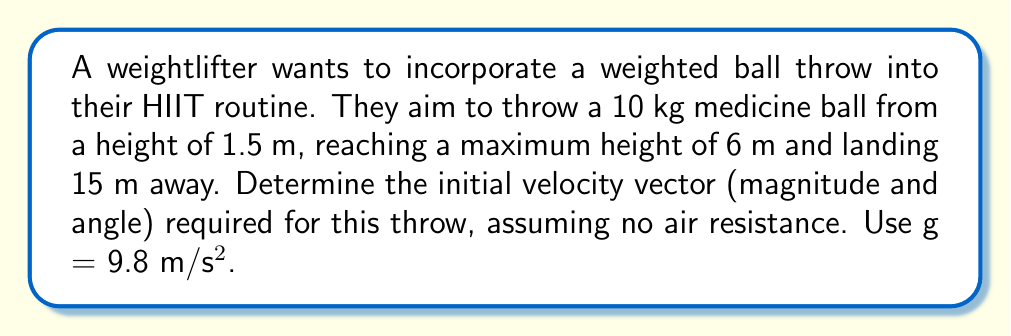Give your solution to this math problem. Let's approach this step-by-step using projectile motion equations:

1) First, we need to find the time of flight. We can use the vertical displacement equation:

   $$y = y_0 + v_0y t - \frac{1}{2}gt^2$$

   At the landing point: $0 = 1.5 + v_0y t - \frac{1}{2}(9.8)t^2$

2) We also know that at the highest point, $v_y = 0$. Using $v_y = v_0y - gt$, we can find $t_{max}$:

   $$0 = v_0y - 9.8t_{max}$$
   $$t_{max} = \frac{v_0y}{9.8}$$

3) The total time is twice $t_{max}$. Substituting this into the equation from step 1:

   $$0 = 1.5 + v_0y (\frac{2v_0y}{9.8}) - \frac{1}{2}(9.8)(\frac{2v_0y}{9.8})^2$$

4) Simplifying:

   $$0 = 1.5 + \frac{2v_0y^2}{9.8} - \frac{2v_0y^2}{9.8}$$
   $$-1.5 = 0$$

   This is always true, so we need another equation.

5) We can use the maximum height equation:

   $$6 = 1.5 + \frac{v_0y^2}{2(9.8)}$$
   $$v_0y = \sqrt{2(9.8)(4.5)} = 9.38 \text{ m/s}$$

6) Now we can find the total time:

   $$t_{total} = \frac{2v_0y}{9.8} = \frac{2(9.38)}{9.8} = 1.91 \text{ s}$$

7) Using the horizontal displacement equation:

   $$15 = v_0x (1.91)$$
   $$v_0x = 7.85 \text{ m/s}$$

8) The magnitude of the initial velocity:

   $$v_0 = \sqrt{v_0x^2 + v_0y^2} = \sqrt{7.85^2 + 9.38^2} = 12.23 \text{ m/s}$$

9) The angle of the throw:

   $$\theta = \tan^{-1}(\frac{v_0y}{v_0x}) = \tan^{-1}(\frac{9.38}{7.85}) = 50.1°$$
Answer: $v_0 = 12.23 \text{ m/s}, \theta = 50.1°$ 